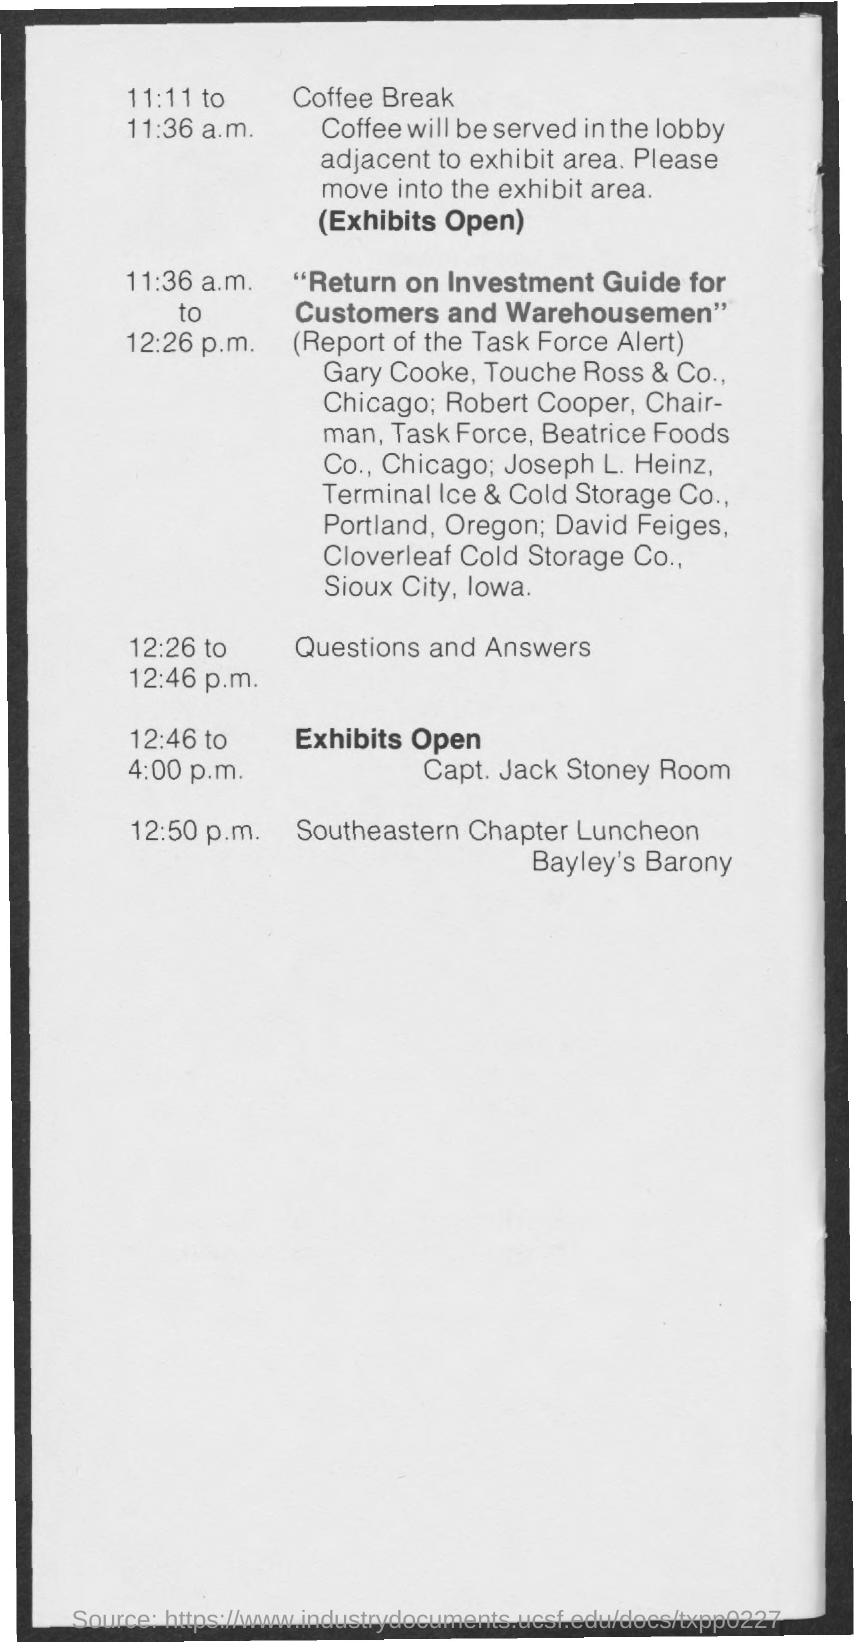When is the coffee break?
Your answer should be very brief. 11:11 TO 11:36 A.M. Where will the coffee be served?
Offer a very short reply. Lobby adjacent to exhibit area. When is the question and answers session?
Give a very brief answer. 12:26 TO 12:46 P.M. What is at 12:50 p.m.?
Provide a short and direct response. Southeastern Chapter Luncheon. 